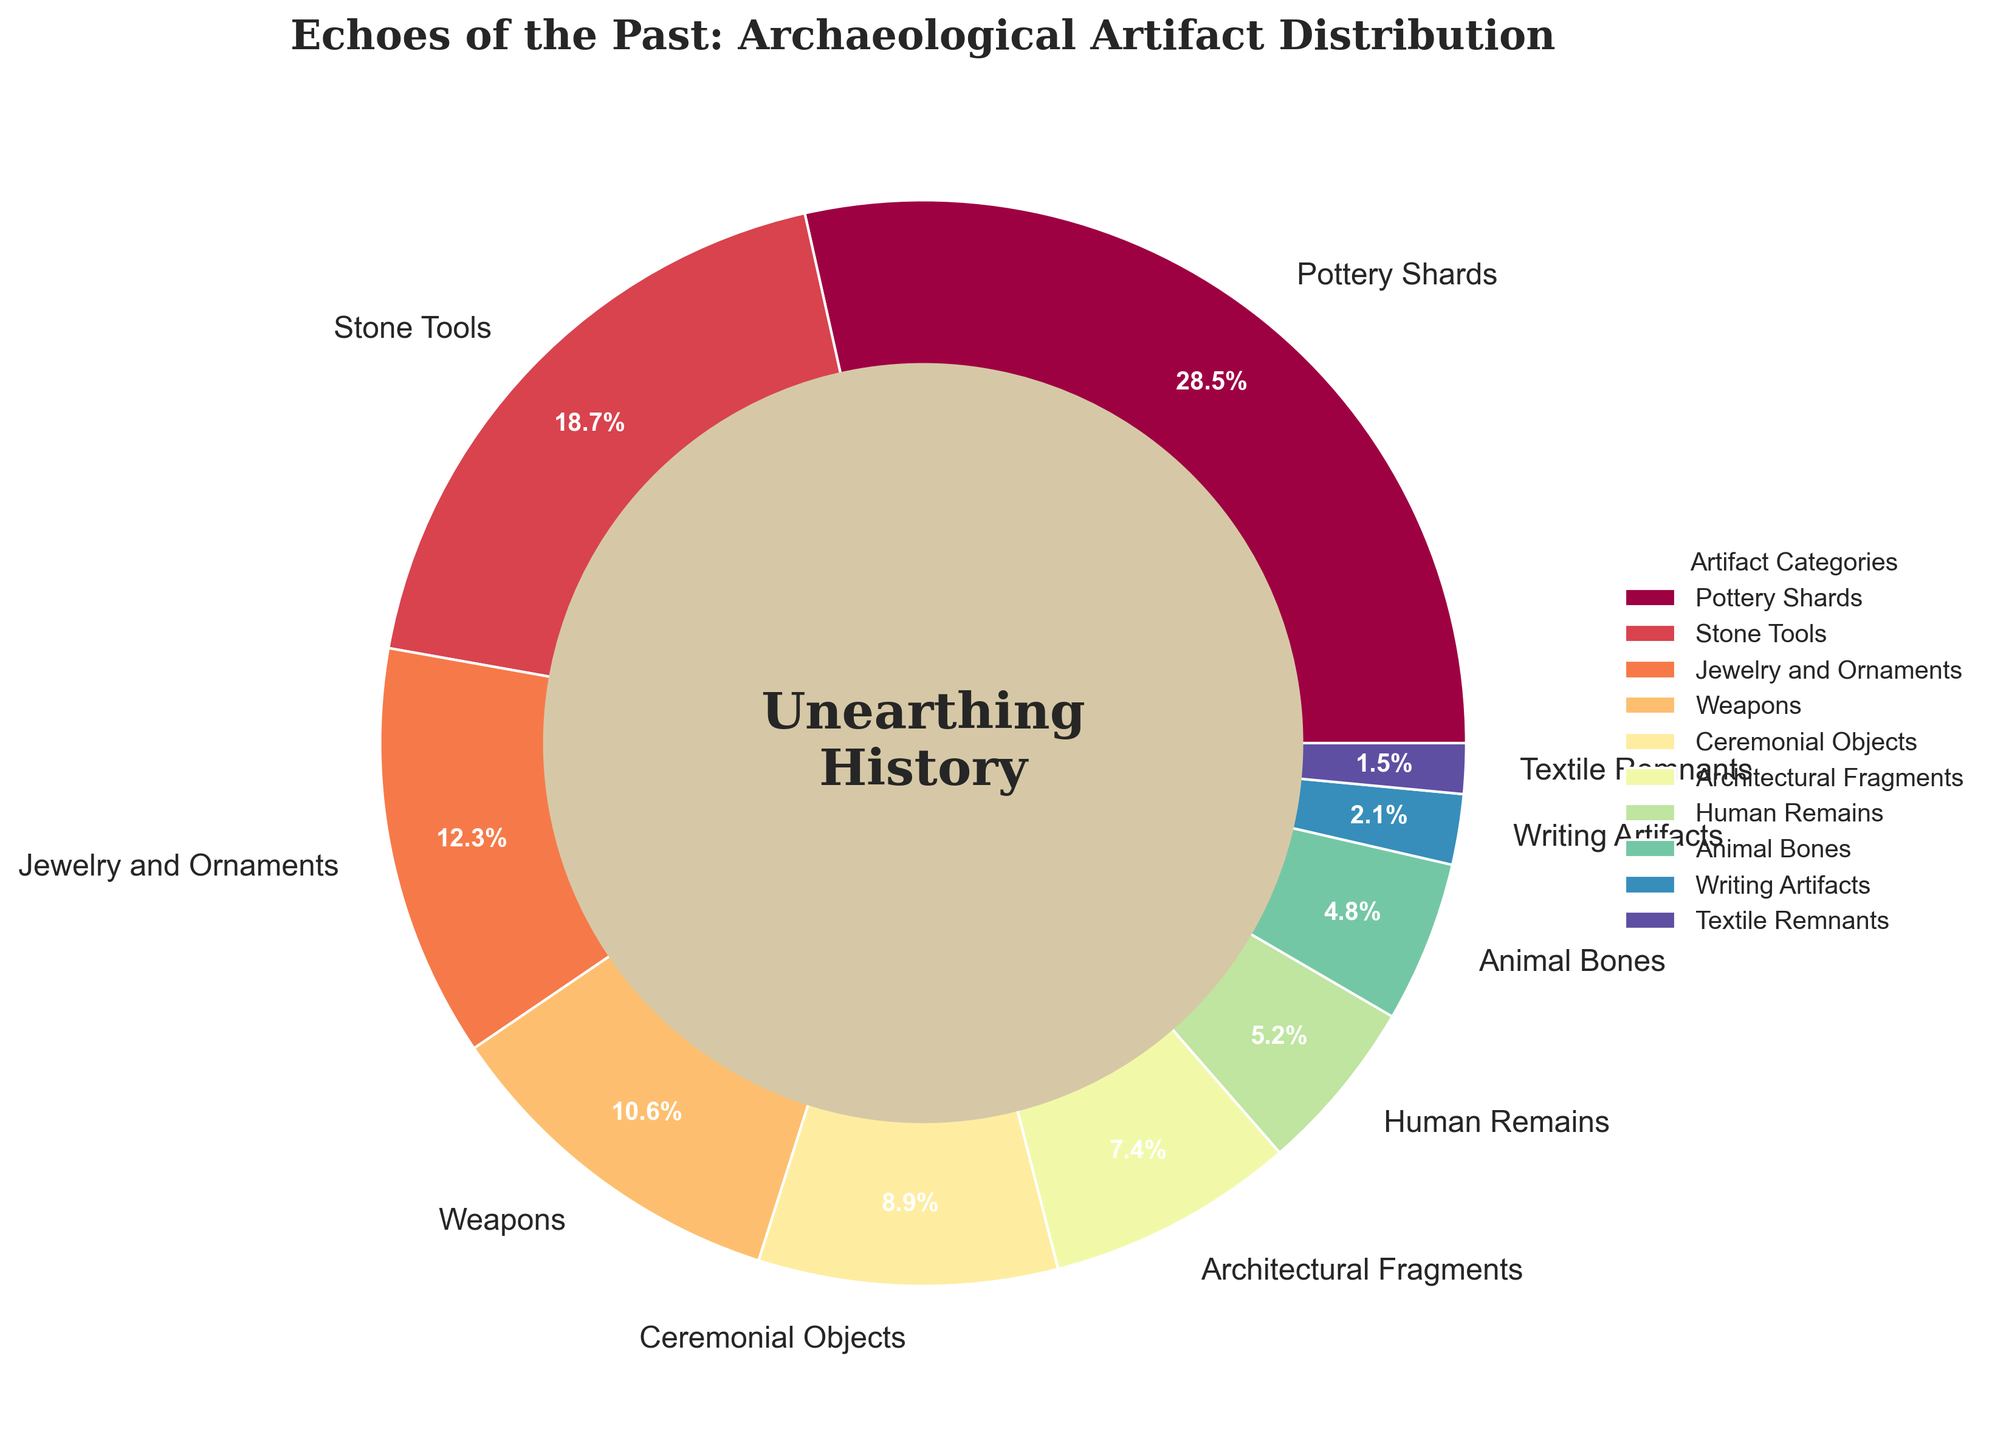Which category has the highest percentage? By looking at the labeled wedges in the pie chart, we can see that "Pottery Shards" have the highest percentage, marked as 28.5%.
Answer: Pottery Shards Which category has the lowest percentage? By observing the chart, "Textile Remnants" have the smallest wedge, with a percentage value indicated as 1.5%.
Answer: Textile Remnants Which two categories together make up more than 40% of the artifacts? "Pottery Shards" make up 28.5% and "Stone Tools" make up 18.7%. Adding these, 28.5% + 18.7% = 47.2%, which is more than 40%.
Answer: Pottery Shards and Stone Tools How much more percentage do Jewelry and Ornaments have compared to Textile Remnants? The percentage for Jewelry and Ornaments is 12.3%, and for Textile Remnants is 1.5%. The difference is 12.3% - 1.5% = 10.8%.
Answer: 10.8% Which categories combined constitute less than 10% of the artifacts? "Textile Remnants" (1.5%) and "Writing Artifacts" (2.1%) sum to 3.6%; adding "Animal Bones" (4.8%) totals 8.4%, which is still less than 10%.
Answer: Textile Remnants, Writing Artifacts, and Animal Bones List all categories that have a percentage more than the average percentage of all categories. First, calculate the average of all percentages. Average = (28.5 + 18.7 + 12.3 + 10.6 + 8.9 + 7.4 + 5.2 + 4.8 + 2.1 + 1.5) / 10 = 10%. Categories with percentages above 10% are "Pottery Shards", "Stone Tools", "Jewelry and Ornaments", and "Weapons".
Answer: Pottery Shards, Stone Tools, Jewelry and Ornaments, Weapons Are there any categories with a percentage exactly equal to 10%? Inspecting the pie chart and the percentage labels, none of the categories have a precise percentage of 10.0%.
Answer: No How many categories have a percentage below 5%? The categories "Human Remains" (5.2%), "Animal Bones" (4.8%), "Writing Artifacts" (2.1%), and "Textile Remnants" (1.5%) show three categories below 5%.
Answer: Three (Animal Bones, Writing Artifacts, Textile Remnants) What is the combined percentage of Ceremonial Objects and Architectural Fragments? The percentage for Ceremonial Objects is 8.9%, and for Architectural Fragments is 7.4%. Adding these, 8.9% + 7.4% = 16.3%.
Answer: 16.3% 